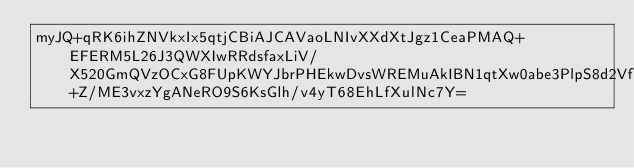Convert code to text. <code><loc_0><loc_0><loc_500><loc_500><_SML_>myJQ+qRK6ihZNVkxIx5qtjCBiAJCAVaoLNIvXXdXtJgz1CeaPMAQ+EFERM5L26J3QWXIwRRdsfaxLiV/X520GmQVzOCxG8FUpKWYJbrPHEkwDvsWREMuAkIBN1qtXw0abe3PlpS8d2VfVftynQhBZEE2o7HZtbgPdd1on+Z/ME3vxzYgANeRO9S6KsGlh/v4yT68EhLfXulNc7Y=</code> 